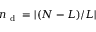Convert formula to latex. <formula><loc_0><loc_0><loc_500><loc_500>n _ { d } = | ( N - L ) / L |</formula> 